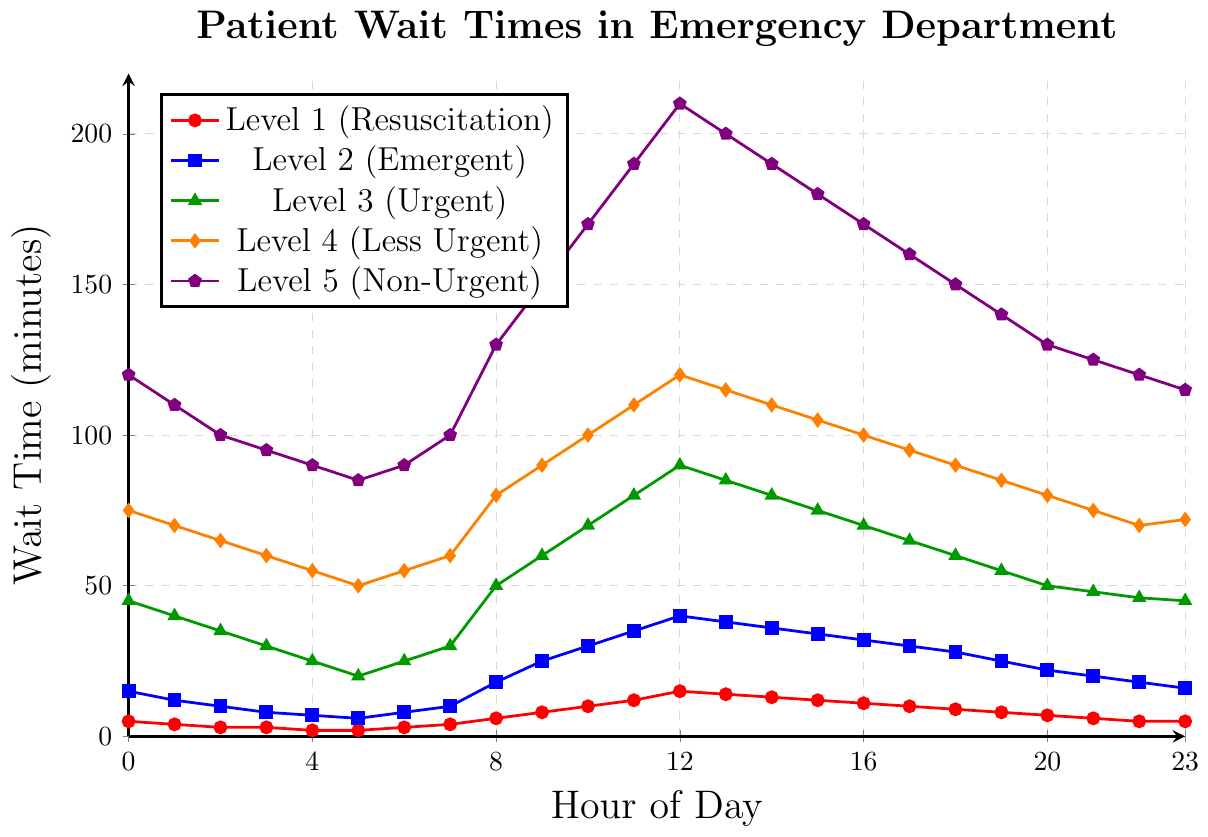what is the wait time for Level 1 (Resuscitation) at 12 PM? To find the wait time for Level 1 (Resuscitation) at 12 PM, look at the data point for hour 12 under "Level 1 (Resuscitation)". The value is 15 minutes.
Answer: 15 minutes How do the wait times for Level 2 (Emergent) and Level 4 (Less Urgent) at 3 AM compare? To compare the wait times at 3 AM, look at the data points for hour 3 under "Level 2 (Emergent)" and "Level 4 (Less Urgent)". Level 2 has 8 minutes and Level 4 has 60 minutes, so Level 4 has a much longer wait time.
Answer: Level 4 is longer What is the difference in wait time between Level 3 (Urgent) and Level 5 (Non-Urgent) at 9 AM? To find the difference, look at the data points for hour 9 under "Level 3 (Urgent)" and "Level 5 (Non-Urgent)". The values are 60 minutes and 150 minutes, respectively. The difference is 150 - 60 = 90 minutes.
Answer: 90 minutes At what hour does Level 4 (Less Urgent) have the maximum wait time, and what is that time? Examine the data under "Level 4 (Less Urgent)" to find the maximum wait time. The highest value is at hour 12, and the wait time is 120 minutes.
Answer: 12 PM, 120 minutes Which triage level consistently has the shortest wait times throughout the 24-hour period? Observe the wait times across all hours for each level. Level 1 (Resuscitation) has the shortest wait times at all hours, remaining consistently lower compared to other levels.
Answer: Level 1 (Resuscitation) What are the wait times for Level 5 (Non-Urgent) at the beginning and end of the day, and what is the difference? Look at the data points for hour 0 and hour 23 under "Level 5 (Non-Urgent)". The values are 120 minutes and 115 minutes, respectively. The difference is 120 - 115 = 5 minutes.
Answer: 5 minutes How does the wait time for Level 3 (Urgent) at 8 AM compare to 8 PM? Compare the values at hour 8 and hour 20 under "Level 3 (Urgent)". The values are 50 minutes and 50 minutes, so they are equal.
Answer: Equal What is the overall trend in wait times for Level 2 (Emergent) from 12 AM to 12 PM? Observe the data points from hour 0 to hour 12 under "Level 2 (Emergent)". The wait times generally increase from 15 minutes to 40 minutes, showing an upward trend.
Answer: Increasing Which triage level has the highest increase in wait time from 6 AM to 12 PM? Calculate the difference in wait time from hour 6 to hour 12 for each level. The differences are: Level 1 (12 minutes), Level 2 (32 minutes), Level 3 (65 minutes), Level 4 (65 minutes), Level 5 (120 minutes). Level 5 (Non-Urgent) has the highest increase.
Answer: Level 5 (Non-Urgent) 